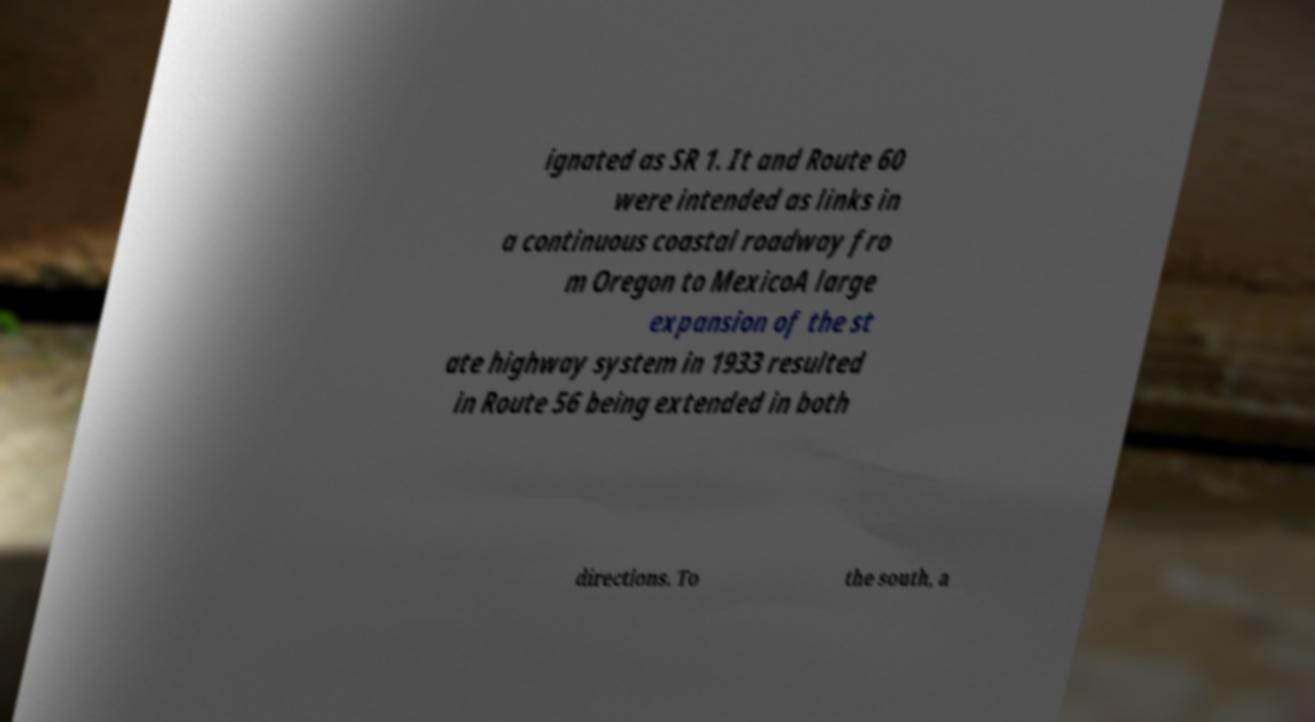Please read and relay the text visible in this image. What does it say? ignated as SR 1. It and Route 60 were intended as links in a continuous coastal roadway fro m Oregon to MexicoA large expansion of the st ate highway system in 1933 resulted in Route 56 being extended in both directions. To the south, a 